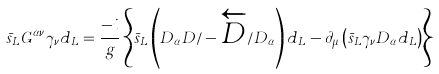<formula> <loc_0><loc_0><loc_500><loc_500>\bar { s } _ { L } { G } ^ { \alpha \nu } \gamma _ { \nu } d _ { L } = \frac { - i } { g } \left \{ \bar { s } _ { L } \left ( D _ { \alpha } D \slash - \overleftarrow { D } \slash D _ { \alpha } \right ) d _ { L } - \partial _ { \mu } \left ( \bar { s } _ { L } \gamma _ { \nu } D _ { \alpha } d _ { L } \right ) \right \}</formula> 